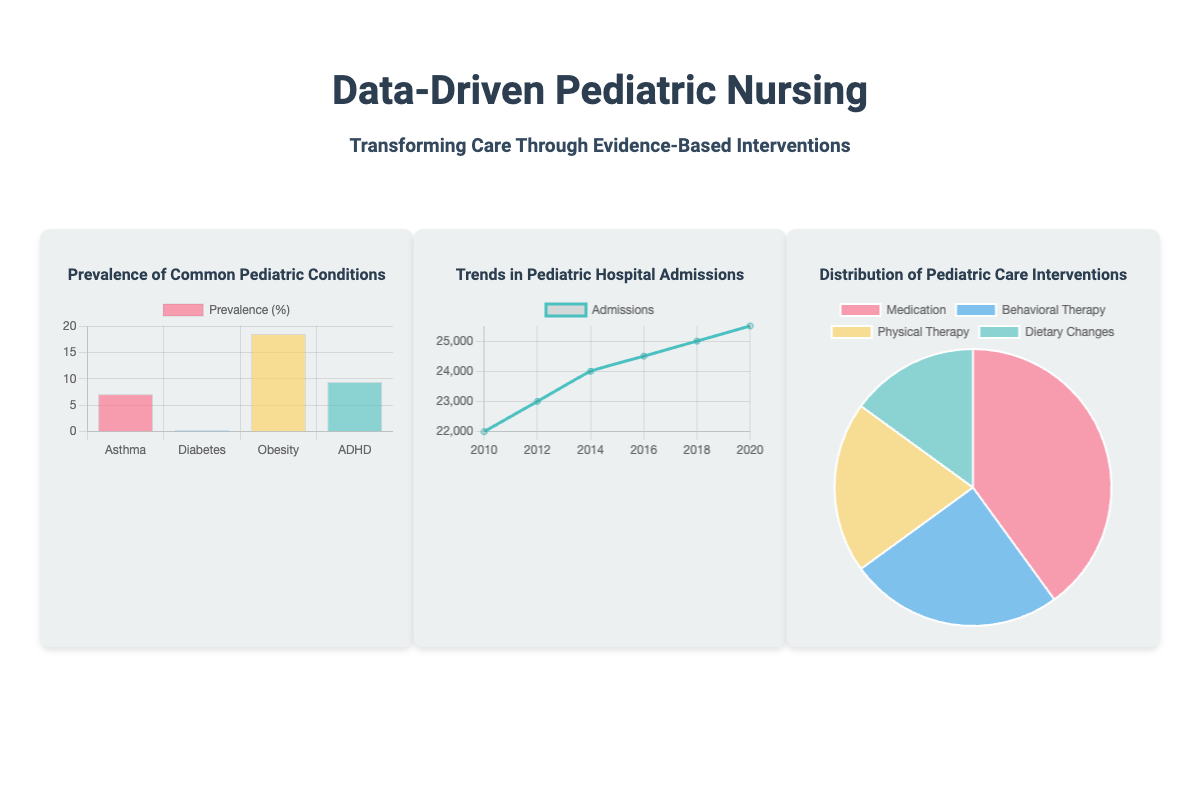What is the title of the book? The title of the book is prominently displayed in large font at the top of the cover.
Answer: Data-Driven Pediatric Nursing What is the subtitle of the book? The subtitle provides further context about the content and purpose of the book, found directly under the title.
Answer: Transforming Care Through Evidence-Based Interventions How many pediatric conditions are represented in the bar chart? The bar chart lists several specific pediatric conditions along the horizontal axis.
Answer: Four What was the highest number of admissions recorded and in which year? The line chart indicates the trend of pediatric hospital admissions over specific years, with the highest value visible.
Answer: 25500 in 2020 What type of chart represents the distribution of pediatric care interventions? The chart showing the different types of interventions is visually categorized in a specific format on the cover.
Answer: Pie chart Which pediatric condition has the highest prevalence percentage according to the bar chart? By examining the data visualized in the bar chart, the condition with the highest percentage can be identified.
Answer: Obesity Which healthcare tool icon appears first in the icons container? The icons displayed represent different healthcare tools, arranged visually from left to right.
Answer: Stethoscope What percentage of interventions is represented by Medication in the pie chart? The pie chart shows the percentages attributed to various interventions, including Medication, by color-coded segments.
Answer: 40% 